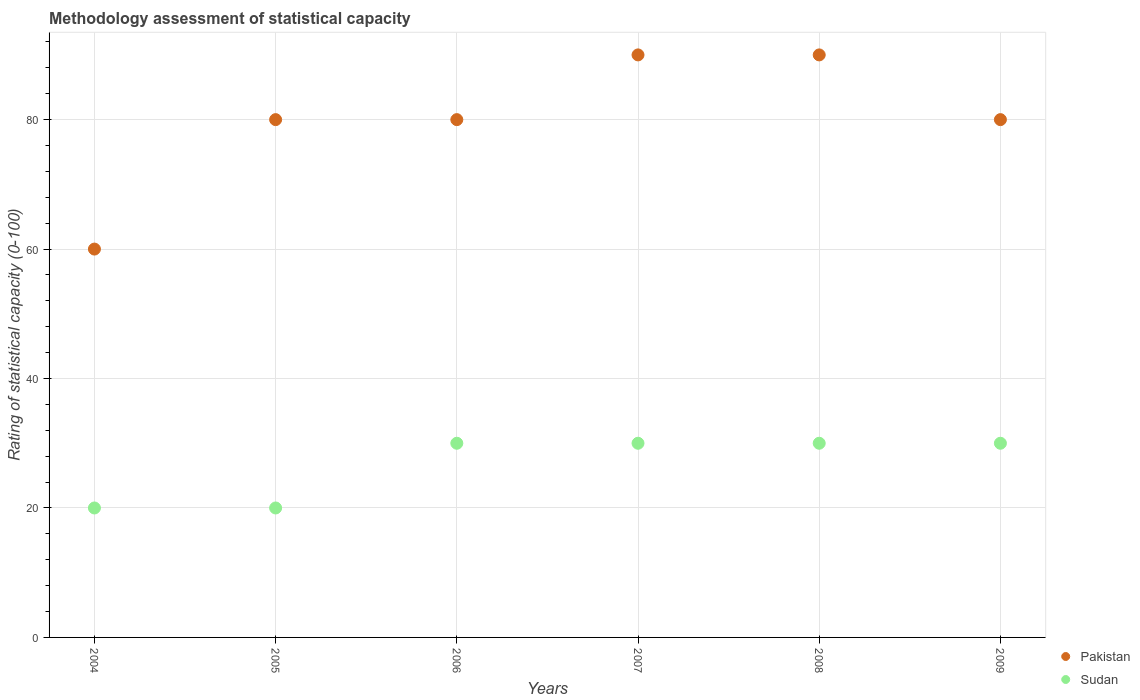Is the number of dotlines equal to the number of legend labels?
Your response must be concise. Yes. What is the rating of statistical capacity in Sudan in 2004?
Ensure brevity in your answer.  20. Across all years, what is the maximum rating of statistical capacity in Pakistan?
Ensure brevity in your answer.  90. Across all years, what is the minimum rating of statistical capacity in Sudan?
Give a very brief answer. 20. In which year was the rating of statistical capacity in Pakistan maximum?
Provide a short and direct response. 2007. In which year was the rating of statistical capacity in Sudan minimum?
Your answer should be compact. 2004. What is the total rating of statistical capacity in Sudan in the graph?
Ensure brevity in your answer.  160. What is the difference between the rating of statistical capacity in Sudan in 2004 and that in 2008?
Offer a terse response. -10. What is the difference between the rating of statistical capacity in Sudan in 2006 and the rating of statistical capacity in Pakistan in 2004?
Your answer should be compact. -30. What is the average rating of statistical capacity in Sudan per year?
Offer a very short reply. 26.67. In the year 2008, what is the difference between the rating of statistical capacity in Pakistan and rating of statistical capacity in Sudan?
Your answer should be very brief. 60. What is the ratio of the rating of statistical capacity in Sudan in 2005 to that in 2008?
Provide a short and direct response. 0.67. What is the difference between the highest and the lowest rating of statistical capacity in Pakistan?
Your answer should be very brief. 30. Is the sum of the rating of statistical capacity in Pakistan in 2004 and 2009 greater than the maximum rating of statistical capacity in Sudan across all years?
Ensure brevity in your answer.  Yes. Does the rating of statistical capacity in Pakistan monotonically increase over the years?
Provide a succinct answer. No. Is the rating of statistical capacity in Sudan strictly less than the rating of statistical capacity in Pakistan over the years?
Provide a short and direct response. Yes. How many dotlines are there?
Offer a very short reply. 2. Are the values on the major ticks of Y-axis written in scientific E-notation?
Keep it short and to the point. No. Where does the legend appear in the graph?
Offer a terse response. Bottom right. How are the legend labels stacked?
Make the answer very short. Vertical. What is the title of the graph?
Keep it short and to the point. Methodology assessment of statistical capacity. Does "Mauritania" appear as one of the legend labels in the graph?
Provide a short and direct response. No. What is the label or title of the X-axis?
Keep it short and to the point. Years. What is the label or title of the Y-axis?
Provide a short and direct response. Rating of statistical capacity (0-100). What is the Rating of statistical capacity (0-100) of Pakistan in 2004?
Keep it short and to the point. 60. What is the Rating of statistical capacity (0-100) of Sudan in 2004?
Provide a short and direct response. 20. What is the Rating of statistical capacity (0-100) of Sudan in 2005?
Your answer should be compact. 20. What is the Rating of statistical capacity (0-100) in Sudan in 2006?
Offer a terse response. 30. What is the Rating of statistical capacity (0-100) of Pakistan in 2007?
Offer a very short reply. 90. What is the Rating of statistical capacity (0-100) in Sudan in 2007?
Give a very brief answer. 30. What is the Rating of statistical capacity (0-100) of Pakistan in 2008?
Provide a succinct answer. 90. What is the Rating of statistical capacity (0-100) of Sudan in 2008?
Your answer should be compact. 30. What is the Rating of statistical capacity (0-100) in Pakistan in 2009?
Keep it short and to the point. 80. What is the Rating of statistical capacity (0-100) in Sudan in 2009?
Keep it short and to the point. 30. Across all years, what is the maximum Rating of statistical capacity (0-100) of Sudan?
Provide a succinct answer. 30. Across all years, what is the minimum Rating of statistical capacity (0-100) of Pakistan?
Offer a very short reply. 60. Across all years, what is the minimum Rating of statistical capacity (0-100) of Sudan?
Offer a very short reply. 20. What is the total Rating of statistical capacity (0-100) of Pakistan in the graph?
Your answer should be compact. 480. What is the total Rating of statistical capacity (0-100) of Sudan in the graph?
Keep it short and to the point. 160. What is the difference between the Rating of statistical capacity (0-100) in Pakistan in 2004 and that in 2007?
Offer a terse response. -30. What is the difference between the Rating of statistical capacity (0-100) in Pakistan in 2004 and that in 2009?
Provide a succinct answer. -20. What is the difference between the Rating of statistical capacity (0-100) of Sudan in 2004 and that in 2009?
Your answer should be very brief. -10. What is the difference between the Rating of statistical capacity (0-100) in Sudan in 2005 and that in 2006?
Make the answer very short. -10. What is the difference between the Rating of statistical capacity (0-100) in Pakistan in 2005 and that in 2007?
Your response must be concise. -10. What is the difference between the Rating of statistical capacity (0-100) of Pakistan in 2005 and that in 2009?
Keep it short and to the point. 0. What is the difference between the Rating of statistical capacity (0-100) of Pakistan in 2006 and that in 2007?
Keep it short and to the point. -10. What is the difference between the Rating of statistical capacity (0-100) of Sudan in 2006 and that in 2007?
Offer a very short reply. 0. What is the difference between the Rating of statistical capacity (0-100) of Pakistan in 2006 and that in 2008?
Keep it short and to the point. -10. What is the difference between the Rating of statistical capacity (0-100) of Pakistan in 2006 and that in 2009?
Your response must be concise. 0. What is the difference between the Rating of statistical capacity (0-100) in Sudan in 2006 and that in 2009?
Your answer should be compact. 0. What is the difference between the Rating of statistical capacity (0-100) in Sudan in 2007 and that in 2008?
Provide a short and direct response. 0. What is the difference between the Rating of statistical capacity (0-100) of Sudan in 2008 and that in 2009?
Make the answer very short. 0. What is the difference between the Rating of statistical capacity (0-100) of Pakistan in 2004 and the Rating of statistical capacity (0-100) of Sudan in 2006?
Offer a terse response. 30. What is the difference between the Rating of statistical capacity (0-100) of Pakistan in 2005 and the Rating of statistical capacity (0-100) of Sudan in 2006?
Your response must be concise. 50. What is the difference between the Rating of statistical capacity (0-100) in Pakistan in 2005 and the Rating of statistical capacity (0-100) in Sudan in 2007?
Provide a short and direct response. 50. What is the difference between the Rating of statistical capacity (0-100) of Pakistan in 2005 and the Rating of statistical capacity (0-100) of Sudan in 2008?
Make the answer very short. 50. What is the difference between the Rating of statistical capacity (0-100) of Pakistan in 2006 and the Rating of statistical capacity (0-100) of Sudan in 2007?
Offer a terse response. 50. What is the difference between the Rating of statistical capacity (0-100) of Pakistan in 2006 and the Rating of statistical capacity (0-100) of Sudan in 2009?
Ensure brevity in your answer.  50. What is the average Rating of statistical capacity (0-100) in Sudan per year?
Your answer should be very brief. 26.67. In the year 2005, what is the difference between the Rating of statistical capacity (0-100) in Pakistan and Rating of statistical capacity (0-100) in Sudan?
Offer a very short reply. 60. In the year 2006, what is the difference between the Rating of statistical capacity (0-100) in Pakistan and Rating of statistical capacity (0-100) in Sudan?
Your response must be concise. 50. In the year 2009, what is the difference between the Rating of statistical capacity (0-100) of Pakistan and Rating of statistical capacity (0-100) of Sudan?
Provide a succinct answer. 50. What is the ratio of the Rating of statistical capacity (0-100) of Sudan in 2004 to that in 2005?
Your answer should be very brief. 1. What is the ratio of the Rating of statistical capacity (0-100) of Sudan in 2004 to that in 2007?
Your answer should be very brief. 0.67. What is the ratio of the Rating of statistical capacity (0-100) in Sudan in 2004 to that in 2009?
Provide a succinct answer. 0.67. What is the ratio of the Rating of statistical capacity (0-100) in Sudan in 2005 to that in 2007?
Make the answer very short. 0.67. What is the ratio of the Rating of statistical capacity (0-100) in Pakistan in 2005 to that in 2008?
Provide a succinct answer. 0.89. What is the ratio of the Rating of statistical capacity (0-100) in Sudan in 2006 to that in 2007?
Keep it short and to the point. 1. What is the ratio of the Rating of statistical capacity (0-100) in Pakistan in 2006 to that in 2008?
Make the answer very short. 0.89. What is the ratio of the Rating of statistical capacity (0-100) in Sudan in 2006 to that in 2008?
Ensure brevity in your answer.  1. What is the ratio of the Rating of statistical capacity (0-100) of Pakistan in 2006 to that in 2009?
Your response must be concise. 1. What is the ratio of the Rating of statistical capacity (0-100) of Pakistan in 2007 to that in 2008?
Keep it short and to the point. 1. What is the ratio of the Rating of statistical capacity (0-100) of Sudan in 2007 to that in 2008?
Offer a very short reply. 1. What is the ratio of the Rating of statistical capacity (0-100) in Pakistan in 2007 to that in 2009?
Make the answer very short. 1.12. What is the ratio of the Rating of statistical capacity (0-100) in Sudan in 2007 to that in 2009?
Offer a terse response. 1. What is the ratio of the Rating of statistical capacity (0-100) in Sudan in 2008 to that in 2009?
Keep it short and to the point. 1. What is the difference between the highest and the second highest Rating of statistical capacity (0-100) of Pakistan?
Make the answer very short. 0. What is the difference between the highest and the second highest Rating of statistical capacity (0-100) in Sudan?
Your answer should be very brief. 0. 